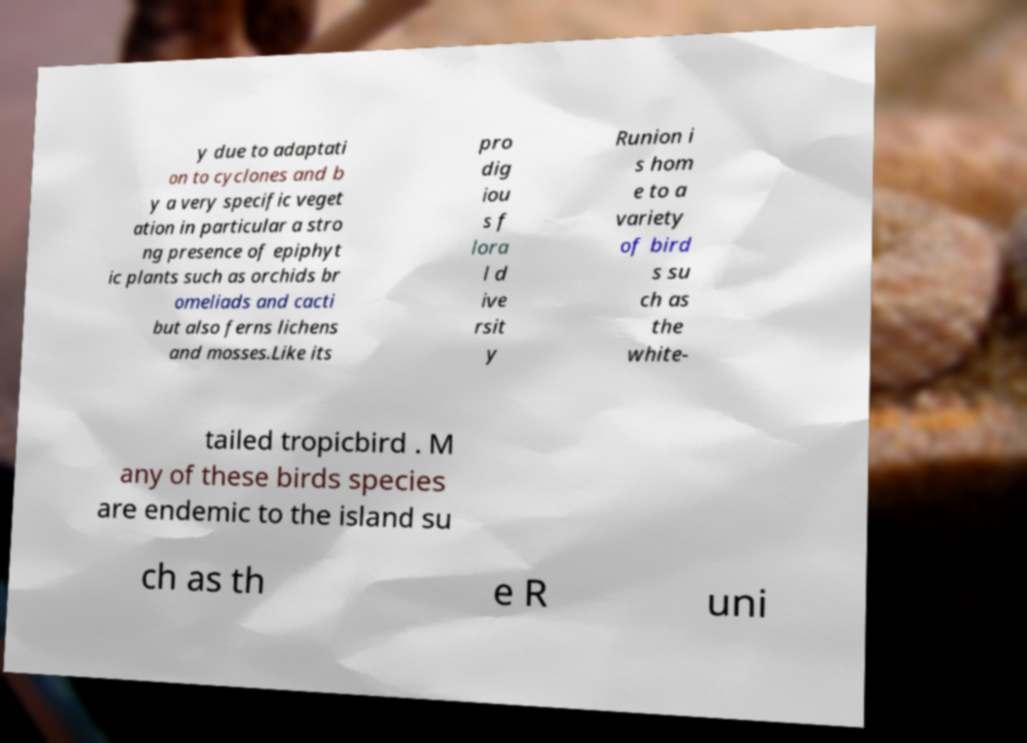For documentation purposes, I need the text within this image transcribed. Could you provide that? y due to adaptati on to cyclones and b y a very specific veget ation in particular a stro ng presence of epiphyt ic plants such as orchids br omeliads and cacti but also ferns lichens and mosses.Like its pro dig iou s f lora l d ive rsit y Runion i s hom e to a variety of bird s su ch as the white- tailed tropicbird . M any of these birds species are endemic to the island su ch as th e R uni 